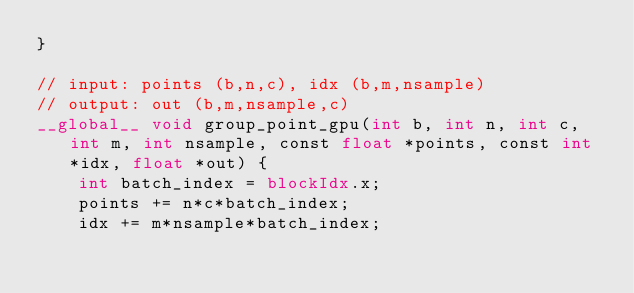<code> <loc_0><loc_0><loc_500><loc_500><_Cuda_>}

// input: points (b,n,c), idx (b,m,nsample)
// output: out (b,m,nsample,c)
__global__ void group_point_gpu(int b, int n, int c, int m, int nsample, const float *points, const int *idx, float *out) {
    int batch_index = blockIdx.x;
    points += n*c*batch_index;
    idx += m*nsample*batch_index;</code> 